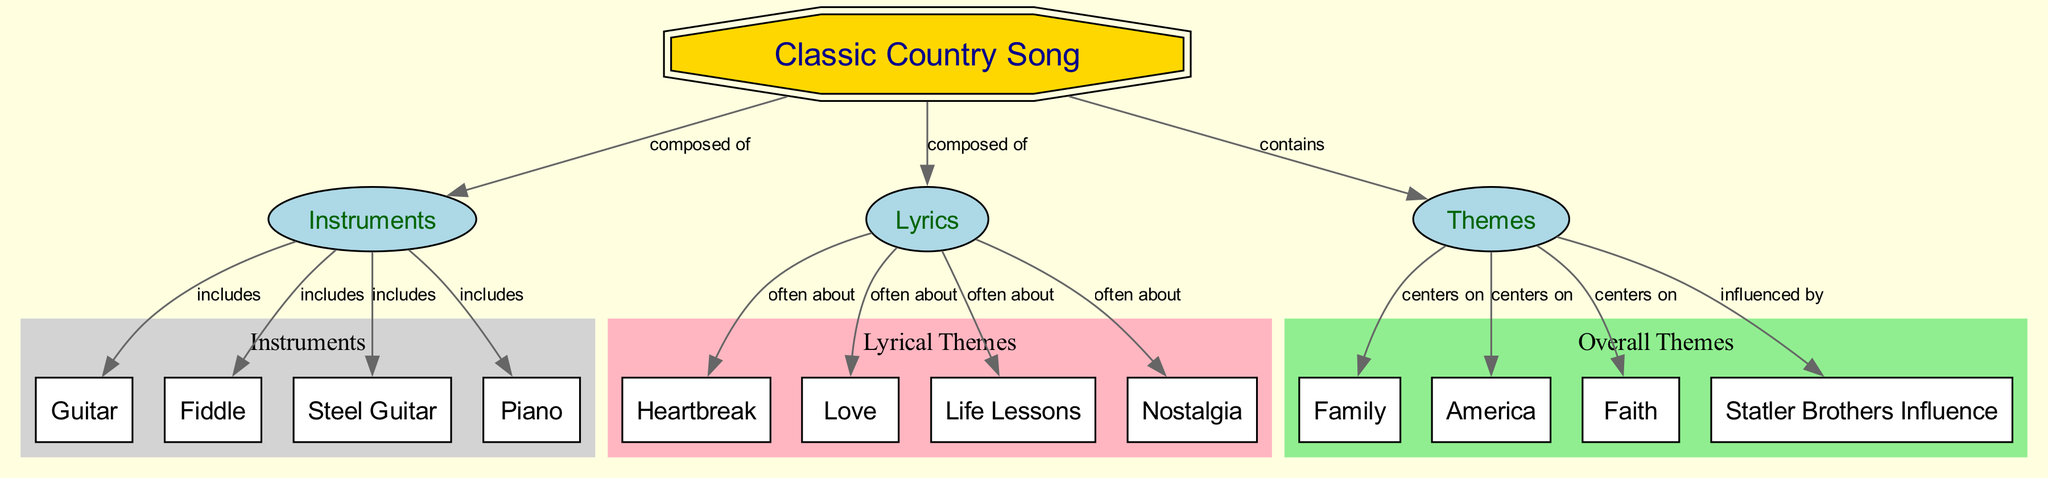What is the main subject of the diagram? The main subject of the diagram is the "Classic Country Song," which is represented as the primary node labeled with a distinct shape.
Answer: Classic Country Song How many instruments are listed in the diagram? To find the number of instruments, we count the nodes connected to the "Instruments" node, which includes Guitar, Fiddle, Steel Guitar, and Piano, totaling four.
Answer: 4 What type of relationship exists between "Classic Country Song" and "Lyrics"? The relationship is that a "Classic Country Song" is composed of "Lyrics," indicating a direct connection in the flowchart structure.
Answer: composed of Which theme centers on "Family"? The theme that centers on "Family" is connected directly to the "Themes" node, indicating it is one of the major themes of classic country songs.
Answer: Family What is a common subject of the lyrics in a classic country song? The common subjects often found in the lyrics are Heartbreak, Love, Life Lessons, and Nostalgia; Heartbreak is one example.
Answer: Heartbreak How many themes are directly influenced by the Statler Brothers? By examining the connections from the "Themes" node, three themes are listed that are influenced by the Statler Brothers: Family, America, and Faith.
Answer: 3 Which instrument is included alongside the Fiddle? By looking at the connections branching from the "Instruments" node, we can see that the Steel Guitar is one of the instruments included alongside the Fiddle.
Answer: Steel Guitar What lyrical theme often relates to "Nostalgia"? The lyrical theme that often relates to "Nostalgia" is the emotional aspect found in songs, indicating a connection to past experiences and memories.
Answer: Nostalgia 